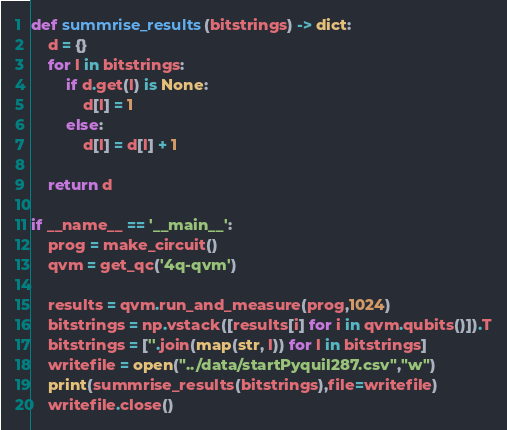Convert code to text. <code><loc_0><loc_0><loc_500><loc_500><_Python_>
def summrise_results(bitstrings) -> dict:
    d = {}
    for l in bitstrings:
        if d.get(l) is None:
            d[l] = 1
        else:
            d[l] = d[l] + 1

    return d

if __name__ == '__main__':
    prog = make_circuit()
    qvm = get_qc('4q-qvm')

    results = qvm.run_and_measure(prog,1024)
    bitstrings = np.vstack([results[i] for i in qvm.qubits()]).T
    bitstrings = [''.join(map(str, l)) for l in bitstrings]
    writefile = open("../data/startPyquil287.csv","w")
    print(summrise_results(bitstrings),file=writefile)
    writefile.close()

</code> 